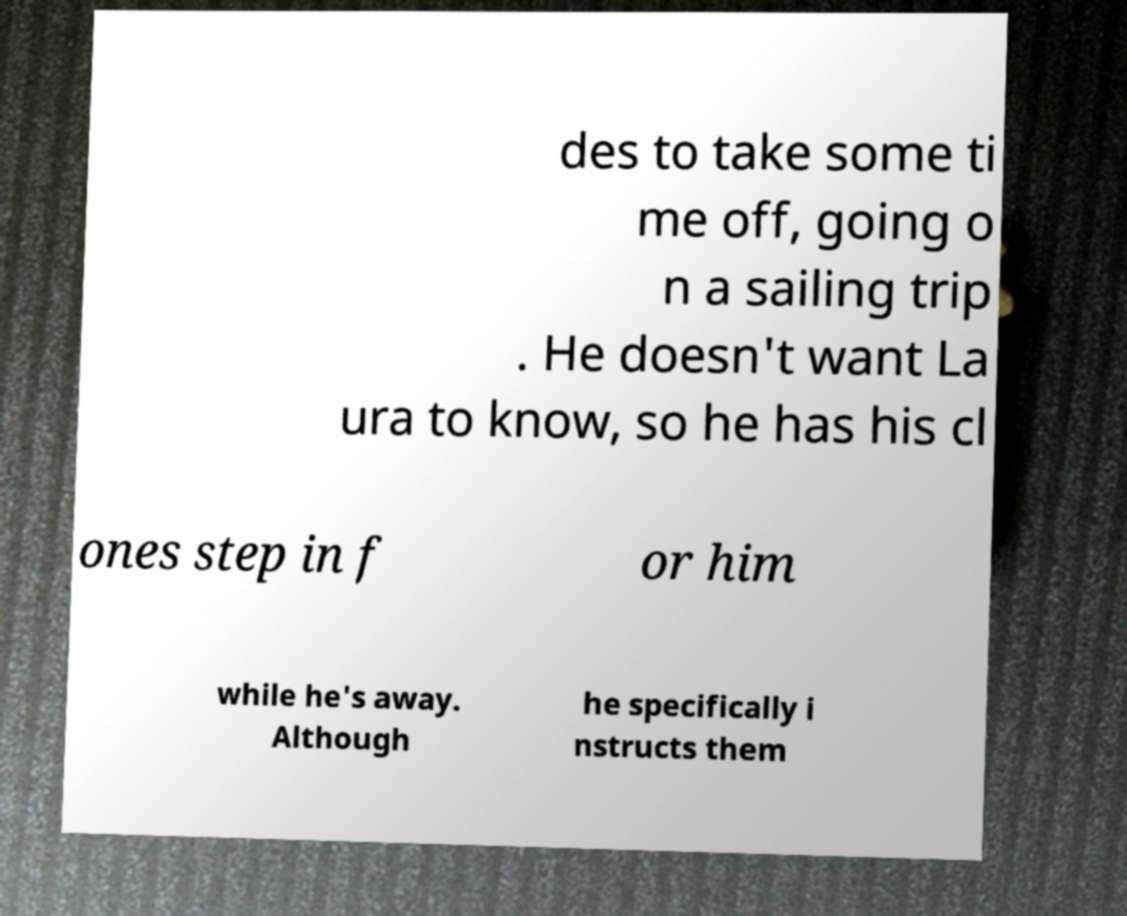Can you accurately transcribe the text from the provided image for me? des to take some ti me off, going o n a sailing trip . He doesn't want La ura to know, so he has his cl ones step in f or him while he's away. Although he specifically i nstructs them 